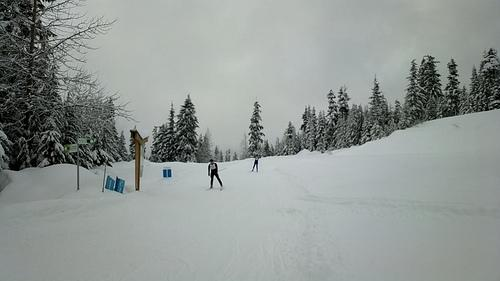Identify the primary activity taking place in the image and the elements involved. People are skiing on a snow-covered mountain, with trees and flags around them, and ski tracks visible in the snow. Explain the human activities visible in the image and any equipment they might be using. People are skiing and using skiing equipment such as skis, ski poles, and winter clothing to navigate the snow-covered mountain. How would you describe the sky in the image? The sky appears cloudy and gray, possibly indicating cold weather conditions. Estimate the number of skiers depicted in the image. There are about six skiers visible in the image. Which type of trees are present in the image and what is unique about them? Evergreen and pine trees are present in the image, and they are all covered in snow, creating a beautiful winter scene. What is the most striking feature of the image related to nature? The evergreen trees covered in snow are the most striking feature of the image related to nature. Explain any interesting interaction between objects or people in the image. One interesting interaction is a person skiing behind another person, possibly following their ski tracks, and skiers skiing down a marked lane. Determine the overall atmosphere or sentiment conveyed by the image. The image conveys a winter sports atmosphere, with people enjoying skiing on a snow-covered mountain among snow-laden trees and cloudy skies. List the distinct objects or signs that can be found on the mountain slope in the image. Distinct objects include white signs attached to a pole, green and white direction signs, light blue and white signs, and a blue flag behind a skier. Describe the conditions and environment of the image. The image features a snowy, mountainous landscape with people skiing, pine trees covered in snow, and a cloudy gray sky above. Can you find a hidden snowman near the tracks in the snow? Observe how the carrot nose and bright red scarf make it stand out among the white snow. No, it's not mentioned in the image. Can you spot the yellow house hidden behind the snow-capped trees at the top left corner of the image, adjacent to the blue flag? Look closely, and you'll see the warm light coming from the windows. There is no mention of a yellow house or any related object in the image's existing captions. Introducing the house with warm lights excites the reader's visual imagination, but isn't a part of the image. Notice the family of deer grazing in the snowy forest to the right of the ski slope. You can clearly see the doe keeping watch while her fawns enjoy their meal. No deer, doe, or fawns are mentioned or represented in the image based on the original captions. By providing an idyllic scene of deer grazing, we pique the reader's curiosity but mislead them, as the image contains none of these elements. 